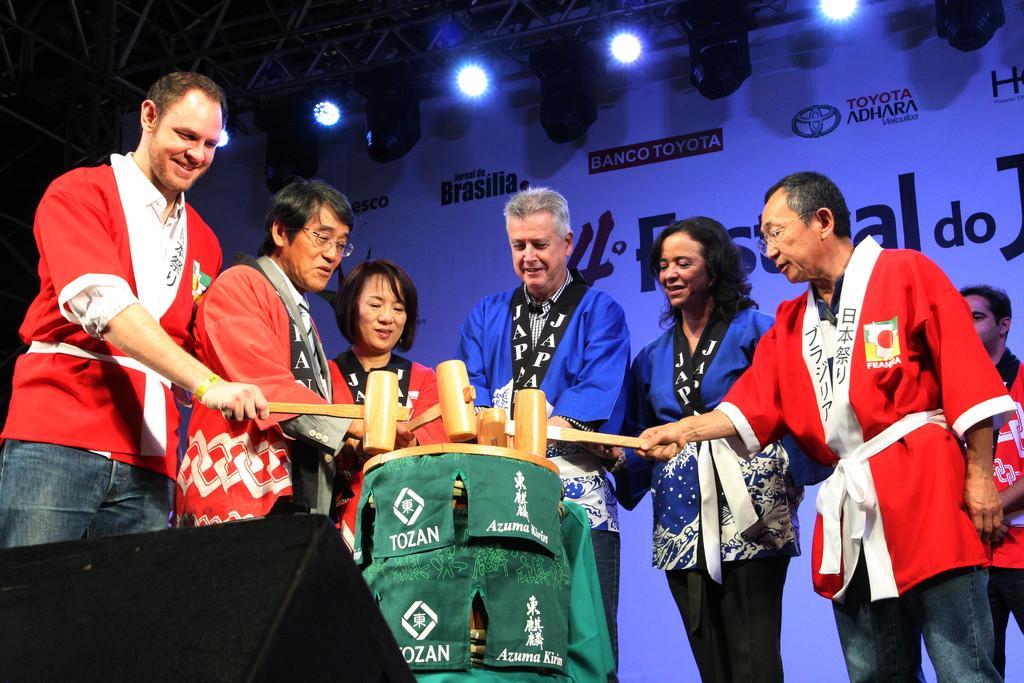Can you describe this image briefly? In this picture I can see there are a few people standing in a group and they are holding hammers and there is a banner in the backdrop and there is something written on it and there are lights attached to the ceiling. 